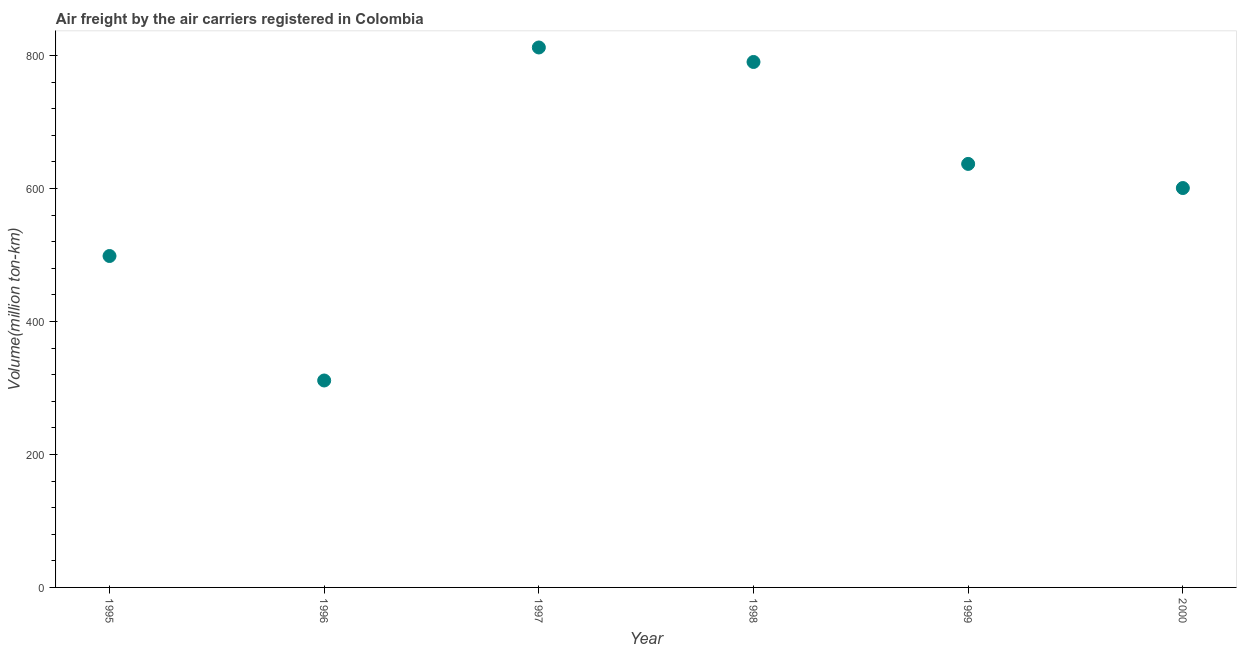What is the air freight in 1996?
Give a very brief answer. 311.2. Across all years, what is the maximum air freight?
Provide a short and direct response. 812. Across all years, what is the minimum air freight?
Make the answer very short. 311.2. What is the sum of the air freight?
Keep it short and to the point. 3649.32. What is the difference between the air freight in 1997 and 1999?
Your answer should be very brief. 175.1. What is the average air freight per year?
Your answer should be compact. 608.22. What is the median air freight?
Keep it short and to the point. 618.76. In how many years, is the air freight greater than 80 million ton-km?
Ensure brevity in your answer.  6. Do a majority of the years between 1995 and 2000 (inclusive) have air freight greater than 320 million ton-km?
Provide a succinct answer. Yes. What is the ratio of the air freight in 1996 to that in 1999?
Make the answer very short. 0.49. Is the difference between the air freight in 1997 and 1998 greater than the difference between any two years?
Offer a terse response. No. What is the difference between the highest and the second highest air freight?
Provide a succinct answer. 21.8. What is the difference between the highest and the lowest air freight?
Your response must be concise. 500.8. Does the air freight monotonically increase over the years?
Offer a terse response. No. How many dotlines are there?
Ensure brevity in your answer.  1. How many years are there in the graph?
Your response must be concise. 6. What is the difference between two consecutive major ticks on the Y-axis?
Your response must be concise. 200. Does the graph contain any zero values?
Provide a short and direct response. No. What is the title of the graph?
Keep it short and to the point. Air freight by the air carriers registered in Colombia. What is the label or title of the Y-axis?
Offer a very short reply. Volume(million ton-km). What is the Volume(million ton-km) in 1995?
Ensure brevity in your answer.  498.4. What is the Volume(million ton-km) in 1996?
Make the answer very short. 311.2. What is the Volume(million ton-km) in 1997?
Your answer should be very brief. 812. What is the Volume(million ton-km) in 1998?
Keep it short and to the point. 790.2. What is the Volume(million ton-km) in 1999?
Your answer should be very brief. 636.9. What is the Volume(million ton-km) in 2000?
Ensure brevity in your answer.  600.62. What is the difference between the Volume(million ton-km) in 1995 and 1996?
Ensure brevity in your answer.  187.2. What is the difference between the Volume(million ton-km) in 1995 and 1997?
Make the answer very short. -313.6. What is the difference between the Volume(million ton-km) in 1995 and 1998?
Your response must be concise. -291.8. What is the difference between the Volume(million ton-km) in 1995 and 1999?
Ensure brevity in your answer.  -138.5. What is the difference between the Volume(million ton-km) in 1995 and 2000?
Your response must be concise. -102.22. What is the difference between the Volume(million ton-km) in 1996 and 1997?
Make the answer very short. -500.8. What is the difference between the Volume(million ton-km) in 1996 and 1998?
Offer a very short reply. -479. What is the difference between the Volume(million ton-km) in 1996 and 1999?
Offer a very short reply. -325.7. What is the difference between the Volume(million ton-km) in 1996 and 2000?
Your response must be concise. -289.42. What is the difference between the Volume(million ton-km) in 1997 and 1998?
Keep it short and to the point. 21.8. What is the difference between the Volume(million ton-km) in 1997 and 1999?
Offer a terse response. 175.1. What is the difference between the Volume(million ton-km) in 1997 and 2000?
Give a very brief answer. 211.38. What is the difference between the Volume(million ton-km) in 1998 and 1999?
Keep it short and to the point. 153.3. What is the difference between the Volume(million ton-km) in 1998 and 2000?
Your response must be concise. 189.58. What is the difference between the Volume(million ton-km) in 1999 and 2000?
Provide a succinct answer. 36.28. What is the ratio of the Volume(million ton-km) in 1995 to that in 1996?
Your response must be concise. 1.6. What is the ratio of the Volume(million ton-km) in 1995 to that in 1997?
Your answer should be compact. 0.61. What is the ratio of the Volume(million ton-km) in 1995 to that in 1998?
Give a very brief answer. 0.63. What is the ratio of the Volume(million ton-km) in 1995 to that in 1999?
Make the answer very short. 0.78. What is the ratio of the Volume(million ton-km) in 1995 to that in 2000?
Keep it short and to the point. 0.83. What is the ratio of the Volume(million ton-km) in 1996 to that in 1997?
Your answer should be very brief. 0.38. What is the ratio of the Volume(million ton-km) in 1996 to that in 1998?
Provide a short and direct response. 0.39. What is the ratio of the Volume(million ton-km) in 1996 to that in 1999?
Your response must be concise. 0.49. What is the ratio of the Volume(million ton-km) in 1996 to that in 2000?
Your answer should be very brief. 0.52. What is the ratio of the Volume(million ton-km) in 1997 to that in 1998?
Offer a very short reply. 1.03. What is the ratio of the Volume(million ton-km) in 1997 to that in 1999?
Ensure brevity in your answer.  1.27. What is the ratio of the Volume(million ton-km) in 1997 to that in 2000?
Offer a terse response. 1.35. What is the ratio of the Volume(million ton-km) in 1998 to that in 1999?
Ensure brevity in your answer.  1.24. What is the ratio of the Volume(million ton-km) in 1998 to that in 2000?
Your answer should be very brief. 1.32. What is the ratio of the Volume(million ton-km) in 1999 to that in 2000?
Ensure brevity in your answer.  1.06. 